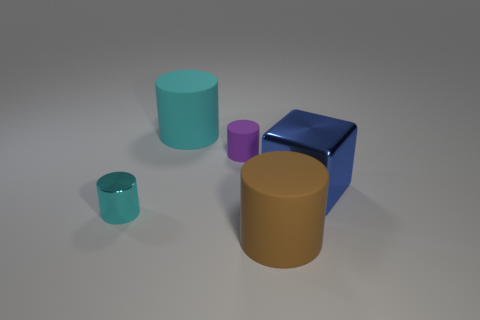Is the number of blue things in front of the brown matte object the same as the number of shiny cylinders that are left of the tiny cyan shiny cylinder?
Offer a terse response. Yes. There is a rubber object that is the same size as the brown cylinder; what is its color?
Provide a short and direct response. Cyan. Is there a shiny ball of the same color as the cube?
Offer a terse response. No. How many objects are small cylinders that are to the left of the purple rubber cylinder or purple metallic blocks?
Your answer should be compact. 1. How many other objects are there of the same size as the cyan metallic thing?
Offer a terse response. 1. What material is the big cylinder that is behind the cylinder on the left side of the large rubber object to the left of the big brown matte object made of?
Provide a succinct answer. Rubber. What number of cylinders are either tiny purple rubber things or cyan matte objects?
Offer a very short reply. 2. Is there anything else that has the same shape as the blue shiny object?
Ensure brevity in your answer.  No. Are there more small cyan shiny cylinders that are in front of the metal cylinder than metal things that are on the left side of the large brown rubber thing?
Provide a short and direct response. No. How many big cyan matte objects are behind the tiny cylinder on the right side of the cyan matte thing?
Your answer should be very brief. 1. 